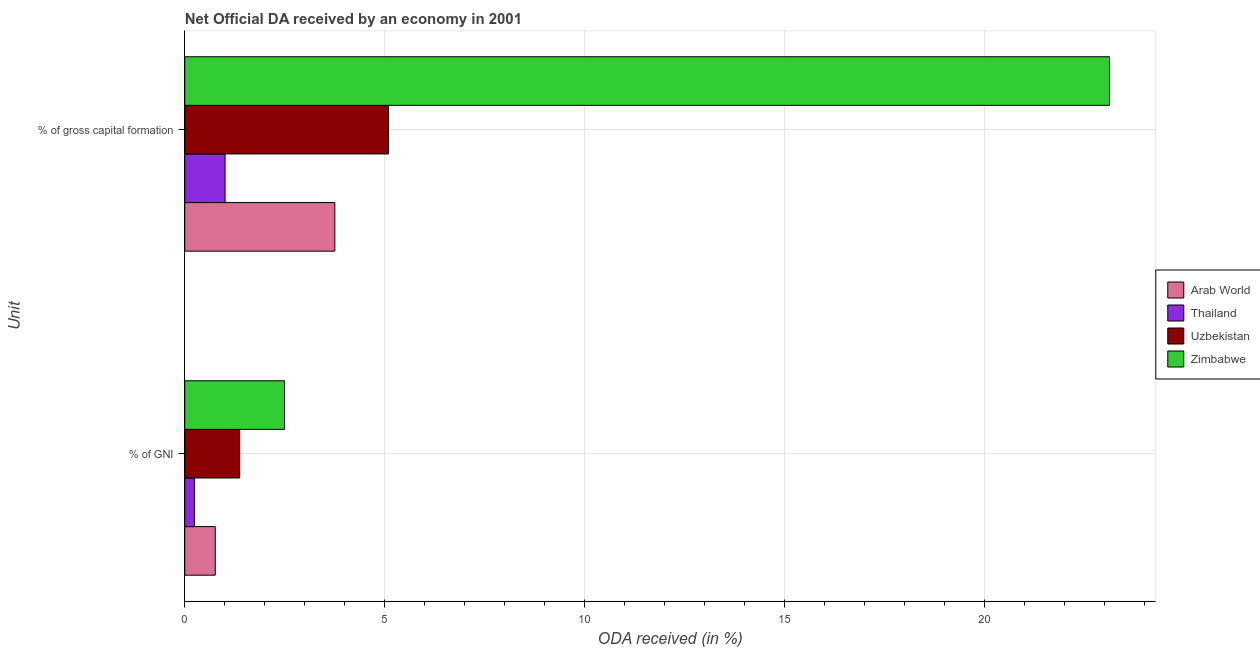How many different coloured bars are there?
Ensure brevity in your answer.  4. How many groups of bars are there?
Give a very brief answer. 2. Are the number of bars per tick equal to the number of legend labels?
Offer a very short reply. Yes. What is the label of the 2nd group of bars from the top?
Your response must be concise. % of GNI. What is the oda received as percentage of gni in Arab World?
Your answer should be compact. 0.76. Across all countries, what is the maximum oda received as percentage of gross capital formation?
Your answer should be compact. 23.13. Across all countries, what is the minimum oda received as percentage of gni?
Offer a very short reply. 0.24. In which country was the oda received as percentage of gni maximum?
Provide a short and direct response. Zimbabwe. In which country was the oda received as percentage of gross capital formation minimum?
Your answer should be very brief. Thailand. What is the total oda received as percentage of gross capital formation in the graph?
Give a very brief answer. 32.98. What is the difference between the oda received as percentage of gni in Zimbabwe and that in Thailand?
Keep it short and to the point. 2.26. What is the difference between the oda received as percentage of gross capital formation in Arab World and the oda received as percentage of gni in Thailand?
Provide a succinct answer. 3.51. What is the average oda received as percentage of gross capital formation per country?
Give a very brief answer. 8.25. What is the difference between the oda received as percentage of gross capital formation and oda received as percentage of gni in Zimbabwe?
Provide a short and direct response. 20.63. What is the ratio of the oda received as percentage of gross capital formation in Zimbabwe to that in Arab World?
Your response must be concise. 6.16. Is the oda received as percentage of gni in Uzbekistan less than that in Thailand?
Ensure brevity in your answer.  No. In how many countries, is the oda received as percentage of gross capital formation greater than the average oda received as percentage of gross capital formation taken over all countries?
Provide a short and direct response. 1. What does the 4th bar from the top in % of GNI represents?
Your response must be concise. Arab World. What does the 1st bar from the bottom in % of GNI represents?
Keep it short and to the point. Arab World. Does the graph contain any zero values?
Your answer should be very brief. No. Where does the legend appear in the graph?
Provide a short and direct response. Center right. How many legend labels are there?
Keep it short and to the point. 4. What is the title of the graph?
Ensure brevity in your answer.  Net Official DA received by an economy in 2001. Does "Bosnia and Herzegovina" appear as one of the legend labels in the graph?
Provide a succinct answer. No. What is the label or title of the X-axis?
Your response must be concise. ODA received (in %). What is the label or title of the Y-axis?
Provide a short and direct response. Unit. What is the ODA received (in %) of Arab World in % of GNI?
Provide a short and direct response. 0.76. What is the ODA received (in %) in Thailand in % of GNI?
Provide a short and direct response. 0.24. What is the ODA received (in %) of Uzbekistan in % of GNI?
Offer a terse response. 1.37. What is the ODA received (in %) in Zimbabwe in % of GNI?
Give a very brief answer. 2.5. What is the ODA received (in %) of Arab World in % of gross capital formation?
Your response must be concise. 3.75. What is the ODA received (in %) in Thailand in % of gross capital formation?
Provide a short and direct response. 1.01. What is the ODA received (in %) in Uzbekistan in % of gross capital formation?
Offer a terse response. 5.09. What is the ODA received (in %) in Zimbabwe in % of gross capital formation?
Provide a succinct answer. 23.13. Across all Unit, what is the maximum ODA received (in %) of Arab World?
Provide a succinct answer. 3.75. Across all Unit, what is the maximum ODA received (in %) in Thailand?
Provide a short and direct response. 1.01. Across all Unit, what is the maximum ODA received (in %) of Uzbekistan?
Make the answer very short. 5.09. Across all Unit, what is the maximum ODA received (in %) in Zimbabwe?
Ensure brevity in your answer.  23.13. Across all Unit, what is the minimum ODA received (in %) in Arab World?
Ensure brevity in your answer.  0.76. Across all Unit, what is the minimum ODA received (in %) of Thailand?
Your answer should be very brief. 0.24. Across all Unit, what is the minimum ODA received (in %) in Uzbekistan?
Offer a terse response. 1.37. Across all Unit, what is the minimum ODA received (in %) of Zimbabwe?
Your response must be concise. 2.5. What is the total ODA received (in %) of Arab World in the graph?
Your answer should be very brief. 4.52. What is the total ODA received (in %) of Thailand in the graph?
Offer a very short reply. 1.25. What is the total ODA received (in %) of Uzbekistan in the graph?
Give a very brief answer. 6.47. What is the total ODA received (in %) of Zimbabwe in the graph?
Offer a terse response. 25.62. What is the difference between the ODA received (in %) in Arab World in % of GNI and that in % of gross capital formation?
Provide a succinct answer. -2.99. What is the difference between the ODA received (in %) of Thailand in % of GNI and that in % of gross capital formation?
Make the answer very short. -0.77. What is the difference between the ODA received (in %) in Uzbekistan in % of GNI and that in % of gross capital formation?
Make the answer very short. -3.72. What is the difference between the ODA received (in %) of Zimbabwe in % of GNI and that in % of gross capital formation?
Give a very brief answer. -20.63. What is the difference between the ODA received (in %) in Arab World in % of GNI and the ODA received (in %) in Thailand in % of gross capital formation?
Your answer should be compact. -0.25. What is the difference between the ODA received (in %) in Arab World in % of GNI and the ODA received (in %) in Uzbekistan in % of gross capital formation?
Provide a short and direct response. -4.33. What is the difference between the ODA received (in %) of Arab World in % of GNI and the ODA received (in %) of Zimbabwe in % of gross capital formation?
Provide a short and direct response. -22.37. What is the difference between the ODA received (in %) in Thailand in % of GNI and the ODA received (in %) in Uzbekistan in % of gross capital formation?
Ensure brevity in your answer.  -4.85. What is the difference between the ODA received (in %) in Thailand in % of GNI and the ODA received (in %) in Zimbabwe in % of gross capital formation?
Offer a terse response. -22.89. What is the difference between the ODA received (in %) in Uzbekistan in % of GNI and the ODA received (in %) in Zimbabwe in % of gross capital formation?
Give a very brief answer. -21.75. What is the average ODA received (in %) of Arab World per Unit?
Provide a succinct answer. 2.26. What is the average ODA received (in %) in Thailand per Unit?
Offer a terse response. 0.62. What is the average ODA received (in %) of Uzbekistan per Unit?
Your response must be concise. 3.23. What is the average ODA received (in %) in Zimbabwe per Unit?
Your answer should be compact. 12.81. What is the difference between the ODA received (in %) in Arab World and ODA received (in %) in Thailand in % of GNI?
Give a very brief answer. 0.52. What is the difference between the ODA received (in %) in Arab World and ODA received (in %) in Uzbekistan in % of GNI?
Your answer should be very brief. -0.61. What is the difference between the ODA received (in %) in Arab World and ODA received (in %) in Zimbabwe in % of GNI?
Keep it short and to the point. -1.73. What is the difference between the ODA received (in %) in Thailand and ODA received (in %) in Uzbekistan in % of GNI?
Offer a terse response. -1.13. What is the difference between the ODA received (in %) of Thailand and ODA received (in %) of Zimbabwe in % of GNI?
Give a very brief answer. -2.26. What is the difference between the ODA received (in %) of Uzbekistan and ODA received (in %) of Zimbabwe in % of GNI?
Keep it short and to the point. -1.12. What is the difference between the ODA received (in %) of Arab World and ODA received (in %) of Thailand in % of gross capital formation?
Your answer should be compact. 2.75. What is the difference between the ODA received (in %) of Arab World and ODA received (in %) of Uzbekistan in % of gross capital formation?
Provide a succinct answer. -1.34. What is the difference between the ODA received (in %) of Arab World and ODA received (in %) of Zimbabwe in % of gross capital formation?
Offer a terse response. -19.38. What is the difference between the ODA received (in %) of Thailand and ODA received (in %) of Uzbekistan in % of gross capital formation?
Provide a short and direct response. -4.08. What is the difference between the ODA received (in %) in Thailand and ODA received (in %) in Zimbabwe in % of gross capital formation?
Provide a succinct answer. -22.12. What is the difference between the ODA received (in %) of Uzbekistan and ODA received (in %) of Zimbabwe in % of gross capital formation?
Provide a short and direct response. -18.04. What is the ratio of the ODA received (in %) of Arab World in % of GNI to that in % of gross capital formation?
Give a very brief answer. 0.2. What is the ratio of the ODA received (in %) in Thailand in % of GNI to that in % of gross capital formation?
Offer a terse response. 0.24. What is the ratio of the ODA received (in %) in Uzbekistan in % of GNI to that in % of gross capital formation?
Your answer should be compact. 0.27. What is the ratio of the ODA received (in %) of Zimbabwe in % of GNI to that in % of gross capital formation?
Make the answer very short. 0.11. What is the difference between the highest and the second highest ODA received (in %) in Arab World?
Your response must be concise. 2.99. What is the difference between the highest and the second highest ODA received (in %) in Thailand?
Provide a short and direct response. 0.77. What is the difference between the highest and the second highest ODA received (in %) in Uzbekistan?
Your response must be concise. 3.72. What is the difference between the highest and the second highest ODA received (in %) of Zimbabwe?
Your response must be concise. 20.63. What is the difference between the highest and the lowest ODA received (in %) in Arab World?
Your answer should be very brief. 2.99. What is the difference between the highest and the lowest ODA received (in %) in Thailand?
Provide a short and direct response. 0.77. What is the difference between the highest and the lowest ODA received (in %) in Uzbekistan?
Make the answer very short. 3.72. What is the difference between the highest and the lowest ODA received (in %) of Zimbabwe?
Your answer should be very brief. 20.63. 